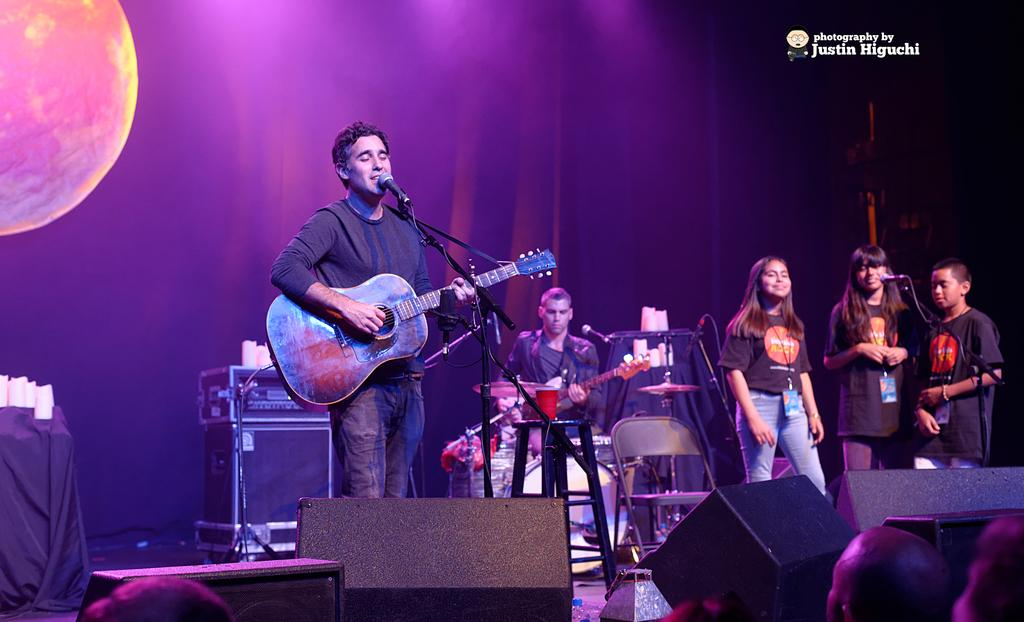What is happening in the image? There is a group of people standing on a stage. What is the man in the image doing? The man is playing a guitar. Where is the man positioned in relation to the microphone? The man is in front of a microphone. What type of shoes is the man wearing while playing the guitar? The image does not show the man's shoes, so it cannot be determined what type of shoes he is wearing. How many letters are visible on the guitar in the image? The image does not show any letters on the guitar, so it cannot be determined how many letters are visible. 